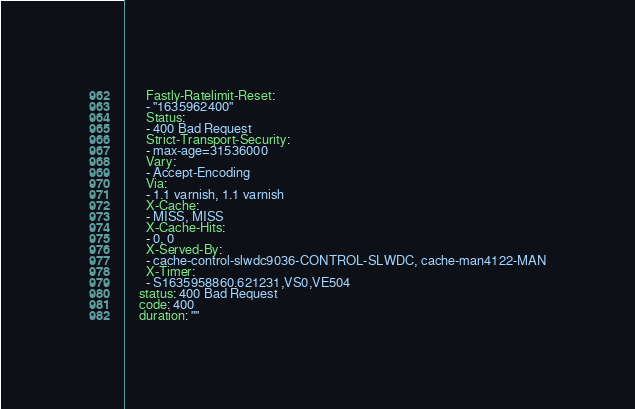Convert code to text. <code><loc_0><loc_0><loc_500><loc_500><_YAML_>      Fastly-Ratelimit-Reset:
      - "1635962400"
      Status:
      - 400 Bad Request
      Strict-Transport-Security:
      - max-age=31536000
      Vary:
      - Accept-Encoding
      Via:
      - 1.1 varnish, 1.1 varnish
      X-Cache:
      - MISS, MISS
      X-Cache-Hits:
      - 0, 0
      X-Served-By:
      - cache-control-slwdc9036-CONTROL-SLWDC, cache-man4122-MAN
      X-Timer:
      - S1635958860.621231,VS0,VE504
    status: 400 Bad Request
    code: 400
    duration: ""
</code> 